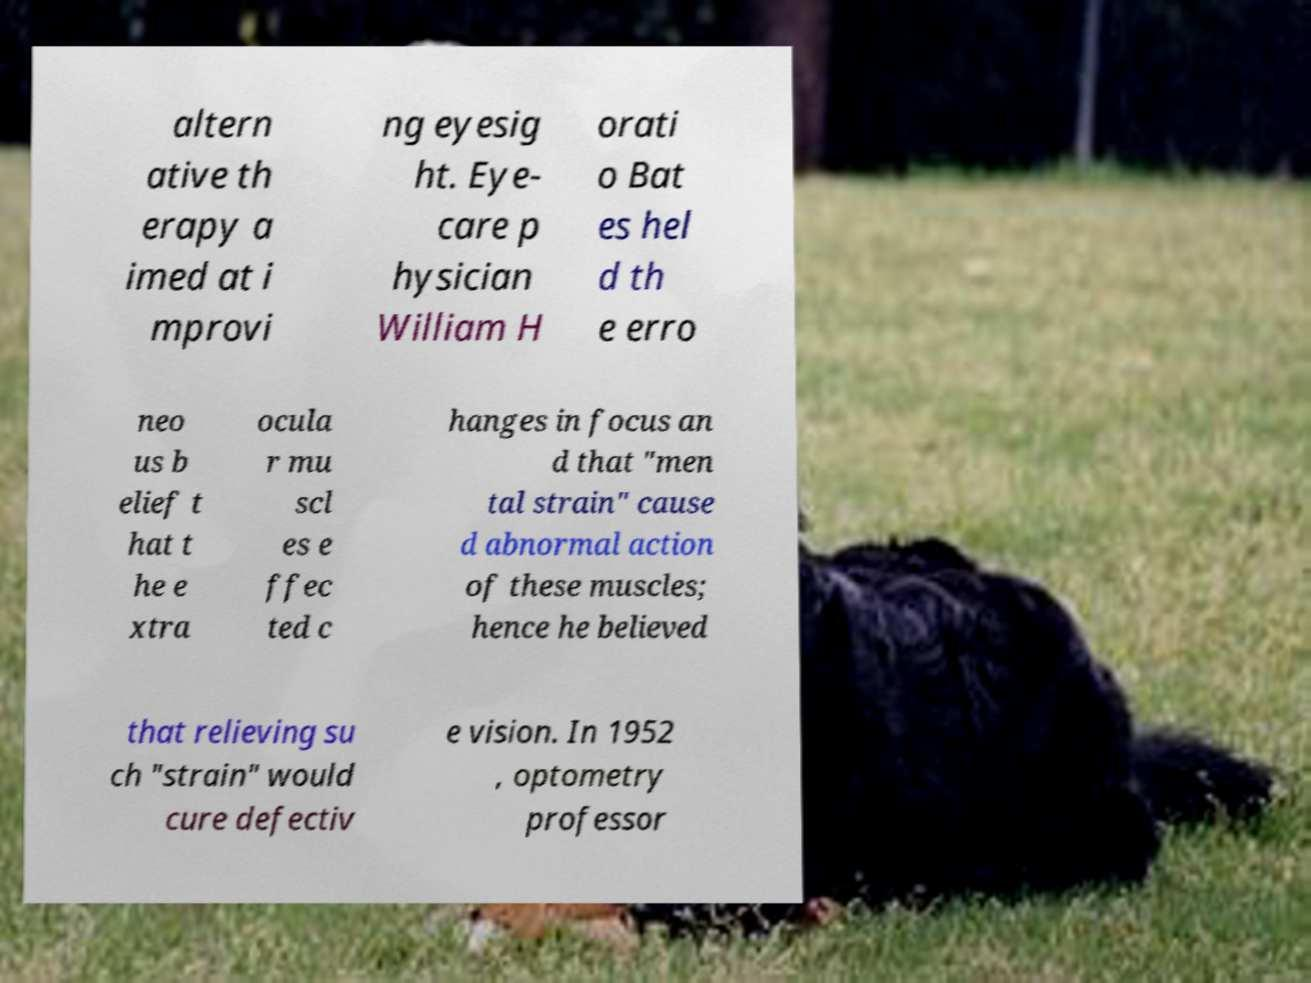Please read and relay the text visible in this image. What does it say? altern ative th erapy a imed at i mprovi ng eyesig ht. Eye- care p hysician William H orati o Bat es hel d th e erro neo us b elief t hat t he e xtra ocula r mu scl es e ffec ted c hanges in focus an d that "men tal strain" cause d abnormal action of these muscles; hence he believed that relieving su ch "strain" would cure defectiv e vision. In 1952 , optometry professor 